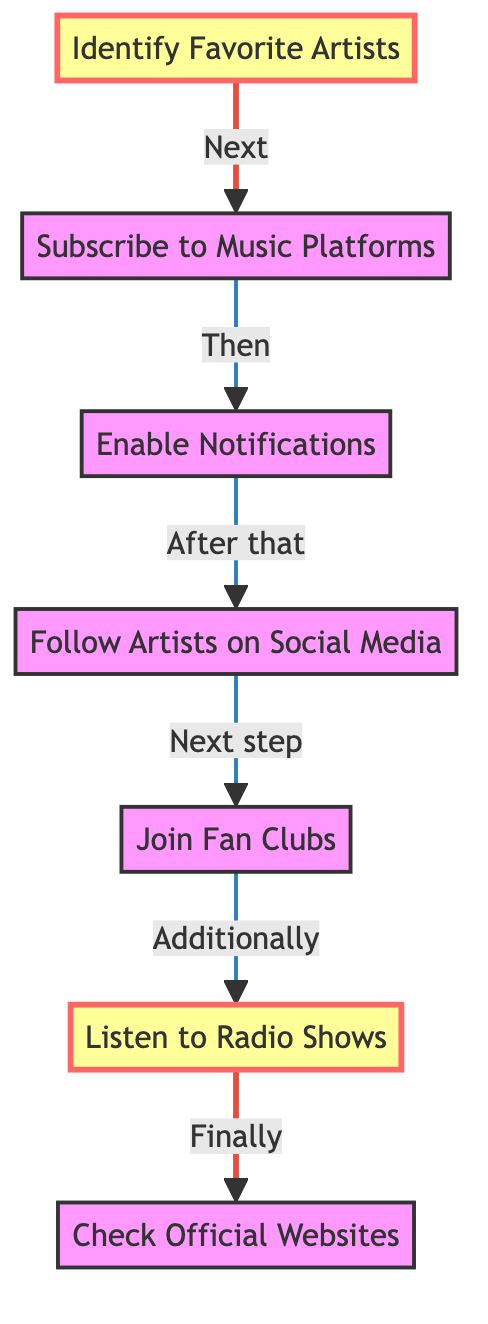What is the first step in the process? The diagram indicates that the first step is "Identify Favorite Artists", as it is the starting node of the flowchart.
Answer: Identify Favorite Artists How many total steps are there in the flowchart? By counting the nodes in the flowchart, we find that there are seven distinct steps listed in the process.
Answer: 7 What step comes immediately after "Subscribe to Music Platforms"? Looking at the flowchart, "Enable Notifications" directly follows the step "Subscribe to Music Platforms", indicating the next action to take.
Answer: Enable Notifications Which steps are highlighted in the diagram? The highlighted steps in the flowchart are "Identify Favorite Artists" and "Listen to Radio Shows", indicating their importance or emphasis in the process.
Answer: Identify Favorite Artists, Listen to Radio Shows What is the relationship between "Follow Artists on Social Media" and "Join Fan Clubs"? The diagram shows a sequential flow where "Follow Artists on Social Media" leads directly to "Join Fan Clubs", indicating that one follows the other in the process.
Answer: Sequential flow What action should be taken before "Check Official Websites"? According to the flowchart, the action that precedes "Check Official Websites" is "Listen to Radio Shows", establishing the order of activities.
Answer: Listen to Radio Shows Which platforms can you subscribe to for song notifications? The flowchart suggests subscribing to "Spotify, Apple Music, and YouTube Music" as music platforms for notifications about new releases.
Answer: Spotify, Apple Music, YouTube Music What is the last step in the flowchart? The last step, as indicated by the flowchart, is "Check Official Websites", marking the final action to take in the process of getting notifications.
Answer: Check Official Websites 